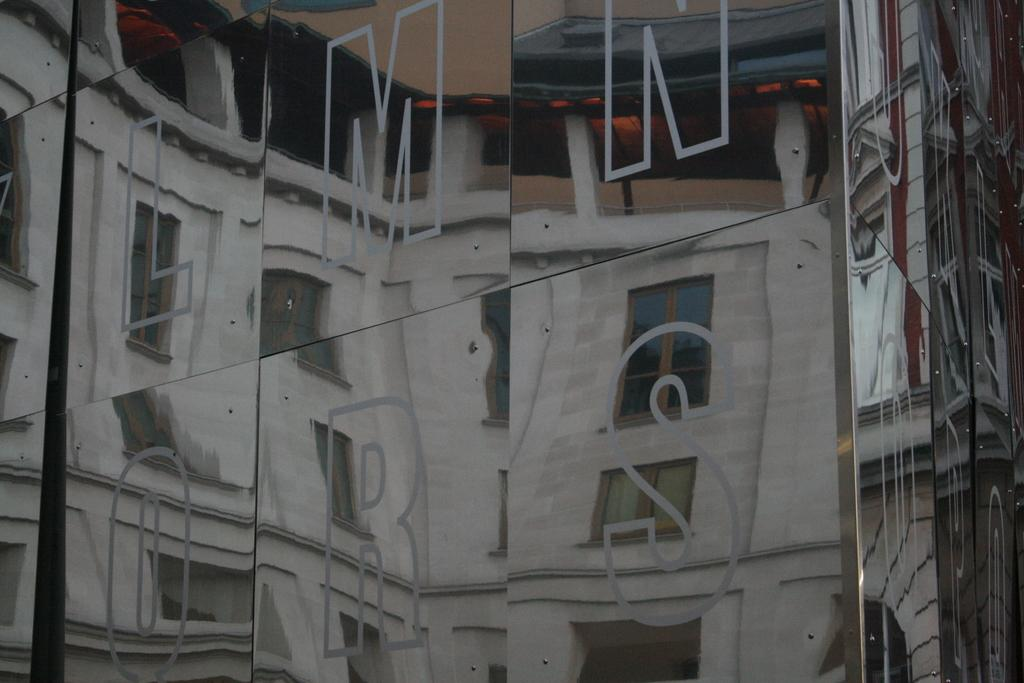What is on the glass wall in the image? There are letters on the glass wall in the image. What does the glass wall allow for in the image? The glass wall allows for the visibility of a building. What feature can be seen on the building in the image? The building has windows. How many dogs can be seen playing with dirt on the wrist of the building in the image? There are no dogs or dirt present in the image, and the building does not have a wrist. 